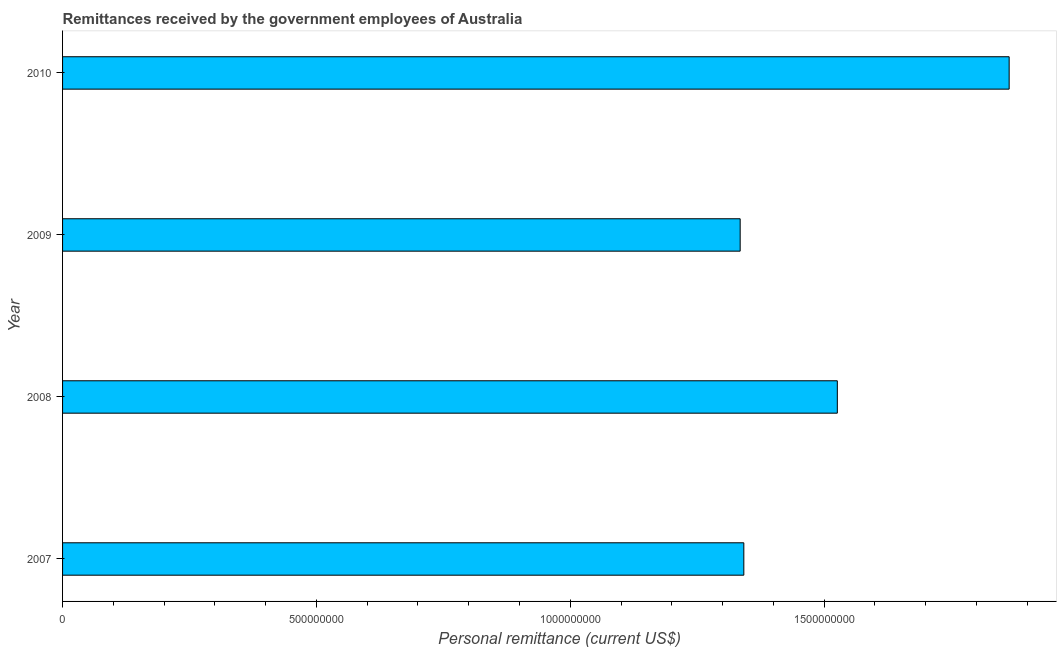What is the title of the graph?
Provide a succinct answer. Remittances received by the government employees of Australia. What is the label or title of the X-axis?
Keep it short and to the point. Personal remittance (current US$). What is the label or title of the Y-axis?
Your answer should be very brief. Year. What is the personal remittances in 2010?
Provide a succinct answer. 1.86e+09. Across all years, what is the maximum personal remittances?
Give a very brief answer. 1.86e+09. Across all years, what is the minimum personal remittances?
Give a very brief answer. 1.33e+09. In which year was the personal remittances minimum?
Your answer should be compact. 2009. What is the sum of the personal remittances?
Keep it short and to the point. 6.07e+09. What is the difference between the personal remittances in 2008 and 2010?
Make the answer very short. -3.38e+08. What is the average personal remittances per year?
Provide a succinct answer. 1.52e+09. What is the median personal remittances?
Make the answer very short. 1.43e+09. Do a majority of the years between 2009 and 2010 (inclusive) have personal remittances greater than 800000000 US$?
Your answer should be compact. Yes. What is the ratio of the personal remittances in 2009 to that in 2010?
Ensure brevity in your answer.  0.72. What is the difference between the highest and the second highest personal remittances?
Make the answer very short. 3.38e+08. What is the difference between the highest and the lowest personal remittances?
Your answer should be very brief. 5.30e+08. In how many years, is the personal remittances greater than the average personal remittances taken over all years?
Give a very brief answer. 2. How many bars are there?
Provide a succinct answer. 4. Are the values on the major ticks of X-axis written in scientific E-notation?
Your answer should be very brief. No. What is the Personal remittance (current US$) in 2007?
Your answer should be very brief. 1.34e+09. What is the Personal remittance (current US$) of 2008?
Offer a terse response. 1.53e+09. What is the Personal remittance (current US$) of 2009?
Your response must be concise. 1.33e+09. What is the Personal remittance (current US$) in 2010?
Ensure brevity in your answer.  1.86e+09. What is the difference between the Personal remittance (current US$) in 2007 and 2008?
Offer a very short reply. -1.84e+08. What is the difference between the Personal remittance (current US$) in 2007 and 2009?
Offer a terse response. 7.20e+06. What is the difference between the Personal remittance (current US$) in 2007 and 2010?
Provide a succinct answer. -5.23e+08. What is the difference between the Personal remittance (current US$) in 2008 and 2009?
Provide a succinct answer. 1.91e+08. What is the difference between the Personal remittance (current US$) in 2008 and 2010?
Your response must be concise. -3.38e+08. What is the difference between the Personal remittance (current US$) in 2009 and 2010?
Ensure brevity in your answer.  -5.30e+08. What is the ratio of the Personal remittance (current US$) in 2007 to that in 2008?
Provide a short and direct response. 0.88. What is the ratio of the Personal remittance (current US$) in 2007 to that in 2009?
Provide a short and direct response. 1. What is the ratio of the Personal remittance (current US$) in 2007 to that in 2010?
Offer a very short reply. 0.72. What is the ratio of the Personal remittance (current US$) in 2008 to that in 2009?
Your response must be concise. 1.14. What is the ratio of the Personal remittance (current US$) in 2008 to that in 2010?
Provide a succinct answer. 0.82. What is the ratio of the Personal remittance (current US$) in 2009 to that in 2010?
Ensure brevity in your answer.  0.72. 